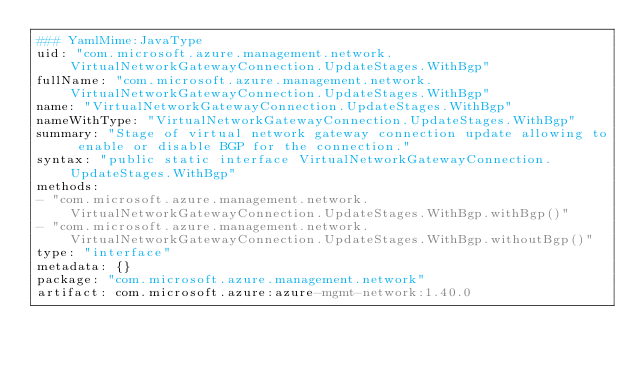Convert code to text. <code><loc_0><loc_0><loc_500><loc_500><_YAML_>### YamlMime:JavaType
uid: "com.microsoft.azure.management.network.VirtualNetworkGatewayConnection.UpdateStages.WithBgp"
fullName: "com.microsoft.azure.management.network.VirtualNetworkGatewayConnection.UpdateStages.WithBgp"
name: "VirtualNetworkGatewayConnection.UpdateStages.WithBgp"
nameWithType: "VirtualNetworkGatewayConnection.UpdateStages.WithBgp"
summary: "Stage of virtual network gateway connection update allowing to enable or disable BGP for the connection."
syntax: "public static interface VirtualNetworkGatewayConnection.UpdateStages.WithBgp"
methods:
- "com.microsoft.azure.management.network.VirtualNetworkGatewayConnection.UpdateStages.WithBgp.withBgp()"
- "com.microsoft.azure.management.network.VirtualNetworkGatewayConnection.UpdateStages.WithBgp.withoutBgp()"
type: "interface"
metadata: {}
package: "com.microsoft.azure.management.network"
artifact: com.microsoft.azure:azure-mgmt-network:1.40.0
</code> 